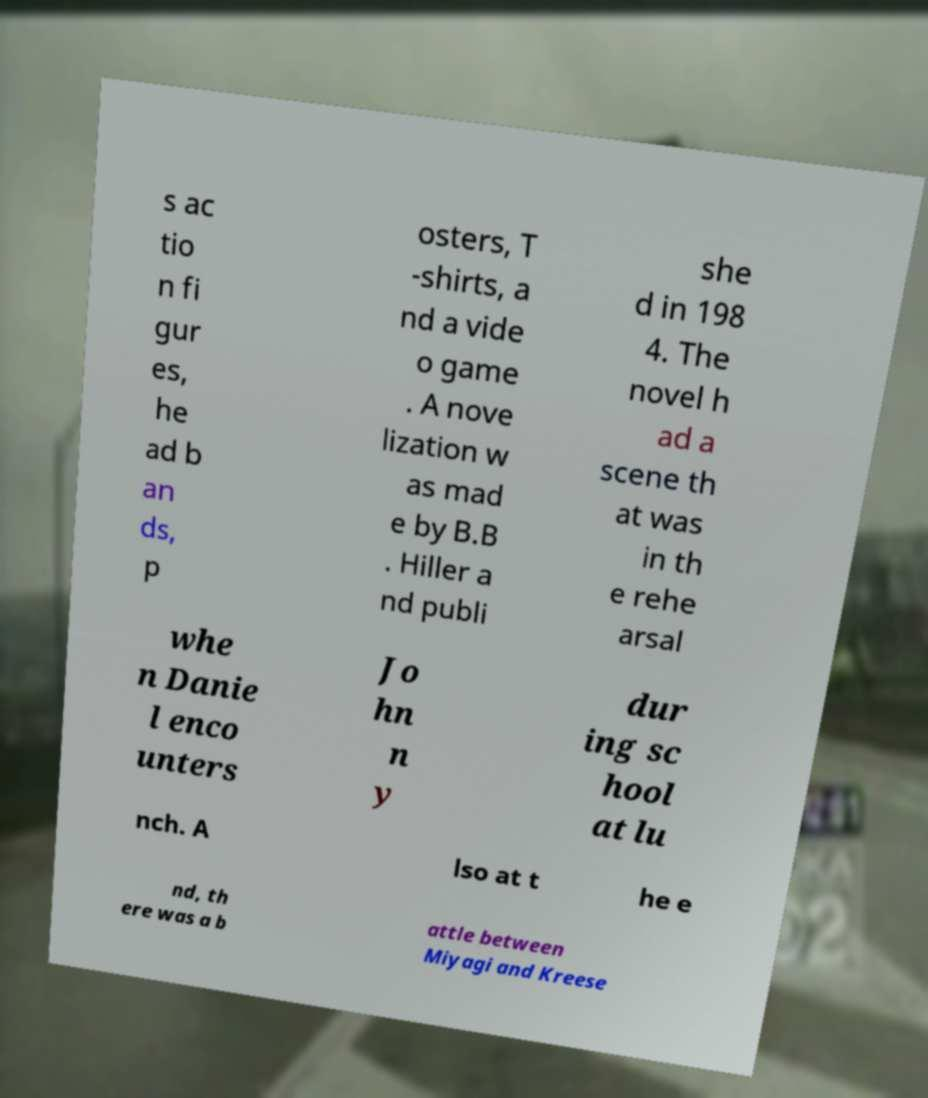There's text embedded in this image that I need extracted. Can you transcribe it verbatim? s ac tio n fi gur es, he ad b an ds, p osters, T -shirts, a nd a vide o game . A nove lization w as mad e by B.B . Hiller a nd publi she d in 198 4. The novel h ad a scene th at was in th e rehe arsal whe n Danie l enco unters Jo hn n y dur ing sc hool at lu nch. A lso at t he e nd, th ere was a b attle between Miyagi and Kreese 